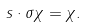Convert formula to latex. <formula><loc_0><loc_0><loc_500><loc_500>s \cdot \sigma \chi = \chi .</formula> 